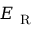<formula> <loc_0><loc_0><loc_500><loc_500>E _ { R }</formula> 